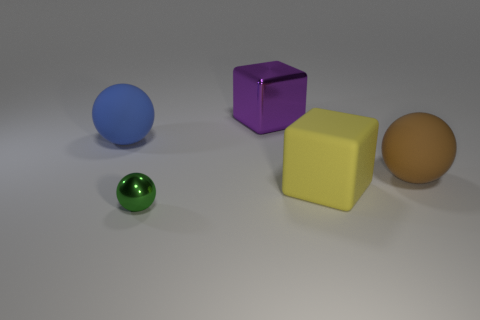Are there more purple shiny cubes left of the matte block than gray shiny cylinders?
Give a very brief answer. Yes. How many objects are either big blue objects or large yellow matte things?
Provide a succinct answer. 2. What is the color of the small shiny ball?
Make the answer very short. Green. Are there any big brown rubber balls on the right side of the green metallic object?
Provide a succinct answer. Yes. What color is the sphere that is on the right side of the metallic object that is on the left side of the large block behind the yellow rubber object?
Provide a short and direct response. Brown. What number of matte things are behind the large yellow object and to the right of the small green shiny thing?
Your answer should be compact. 1. How many cubes are either blue matte objects or tiny green metal things?
Ensure brevity in your answer.  0. Are there any purple metal spheres?
Offer a terse response. No. What number of other things are there of the same material as the large brown thing
Ensure brevity in your answer.  2. What is the material of the brown object that is the same size as the purple thing?
Offer a very short reply. Rubber. 